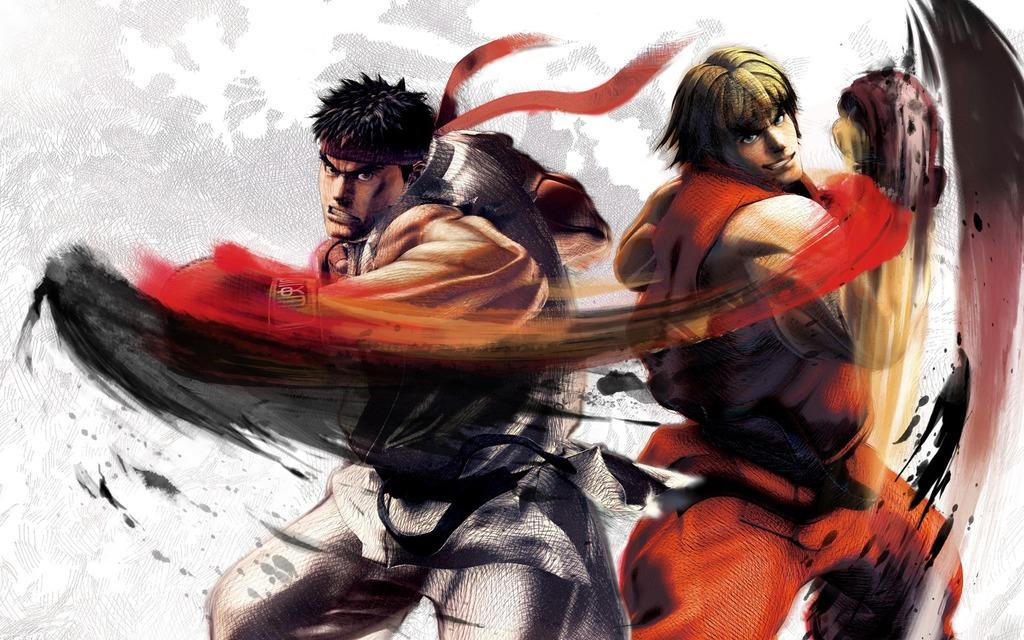What is the main subject of the image? The main subject of the image is a painting. What is depicted in the painting? The painting depicts two people. What are the two people wearing? The two people are wearing different color dresses. How is the background of the painting described? The background of the painting is white and ash in color. What type of thought can be seen in the painting? There is no thought depicted in the painting, as it is a visual representation of two people wearing different color dresses against a white and ash background. 